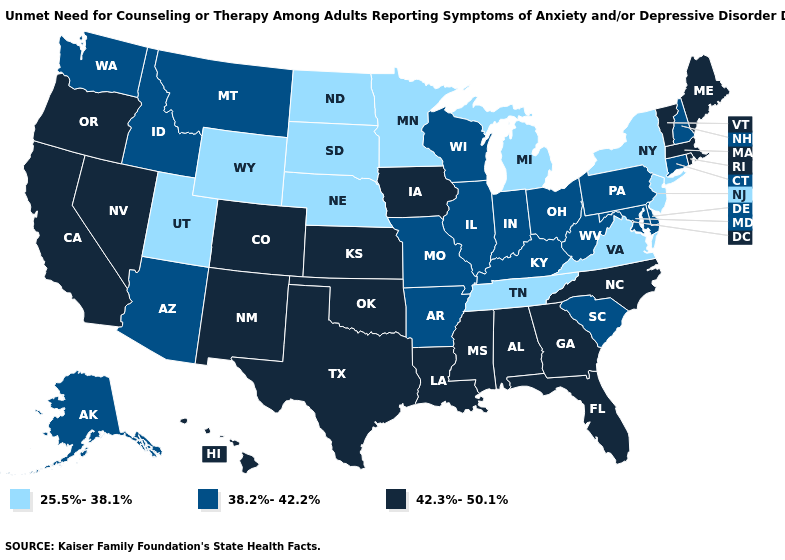Does New York have the highest value in the Northeast?
Keep it brief. No. Does the first symbol in the legend represent the smallest category?
Write a very short answer. Yes. Which states have the highest value in the USA?
Quick response, please. Alabama, California, Colorado, Florida, Georgia, Hawaii, Iowa, Kansas, Louisiana, Maine, Massachusetts, Mississippi, Nevada, New Mexico, North Carolina, Oklahoma, Oregon, Rhode Island, Texas, Vermont. Which states have the highest value in the USA?
Be succinct. Alabama, California, Colorado, Florida, Georgia, Hawaii, Iowa, Kansas, Louisiana, Maine, Massachusetts, Mississippi, Nevada, New Mexico, North Carolina, Oklahoma, Oregon, Rhode Island, Texas, Vermont. What is the value of South Dakota?
Concise answer only. 25.5%-38.1%. Name the states that have a value in the range 25.5%-38.1%?
Write a very short answer. Michigan, Minnesota, Nebraska, New Jersey, New York, North Dakota, South Dakota, Tennessee, Utah, Virginia, Wyoming. Does Iowa have the lowest value in the USA?
Keep it brief. No. Name the states that have a value in the range 25.5%-38.1%?
Keep it brief. Michigan, Minnesota, Nebraska, New Jersey, New York, North Dakota, South Dakota, Tennessee, Utah, Virginia, Wyoming. Is the legend a continuous bar?
Concise answer only. No. What is the value of North Dakota?
Give a very brief answer. 25.5%-38.1%. Name the states that have a value in the range 38.2%-42.2%?
Give a very brief answer. Alaska, Arizona, Arkansas, Connecticut, Delaware, Idaho, Illinois, Indiana, Kentucky, Maryland, Missouri, Montana, New Hampshire, Ohio, Pennsylvania, South Carolina, Washington, West Virginia, Wisconsin. Which states have the lowest value in the USA?
Keep it brief. Michigan, Minnesota, Nebraska, New Jersey, New York, North Dakota, South Dakota, Tennessee, Utah, Virginia, Wyoming. Name the states that have a value in the range 38.2%-42.2%?
Answer briefly. Alaska, Arizona, Arkansas, Connecticut, Delaware, Idaho, Illinois, Indiana, Kentucky, Maryland, Missouri, Montana, New Hampshire, Ohio, Pennsylvania, South Carolina, Washington, West Virginia, Wisconsin. Name the states that have a value in the range 42.3%-50.1%?
Be succinct. Alabama, California, Colorado, Florida, Georgia, Hawaii, Iowa, Kansas, Louisiana, Maine, Massachusetts, Mississippi, Nevada, New Mexico, North Carolina, Oklahoma, Oregon, Rhode Island, Texas, Vermont. Which states hav the highest value in the West?
Keep it brief. California, Colorado, Hawaii, Nevada, New Mexico, Oregon. 